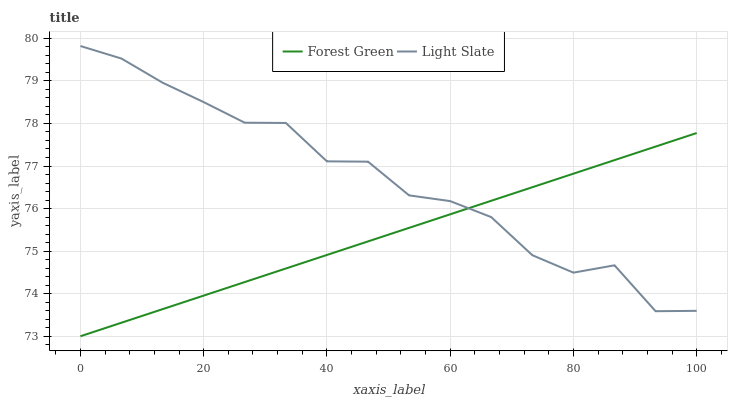Does Forest Green have the minimum area under the curve?
Answer yes or no. Yes. Does Light Slate have the maximum area under the curve?
Answer yes or no. Yes. Does Forest Green have the maximum area under the curve?
Answer yes or no. No. Is Forest Green the smoothest?
Answer yes or no. Yes. Is Light Slate the roughest?
Answer yes or no. Yes. Is Forest Green the roughest?
Answer yes or no. No. Does Forest Green have the lowest value?
Answer yes or no. Yes. Does Light Slate have the highest value?
Answer yes or no. Yes. Does Forest Green have the highest value?
Answer yes or no. No. Does Light Slate intersect Forest Green?
Answer yes or no. Yes. Is Light Slate less than Forest Green?
Answer yes or no. No. Is Light Slate greater than Forest Green?
Answer yes or no. No. 